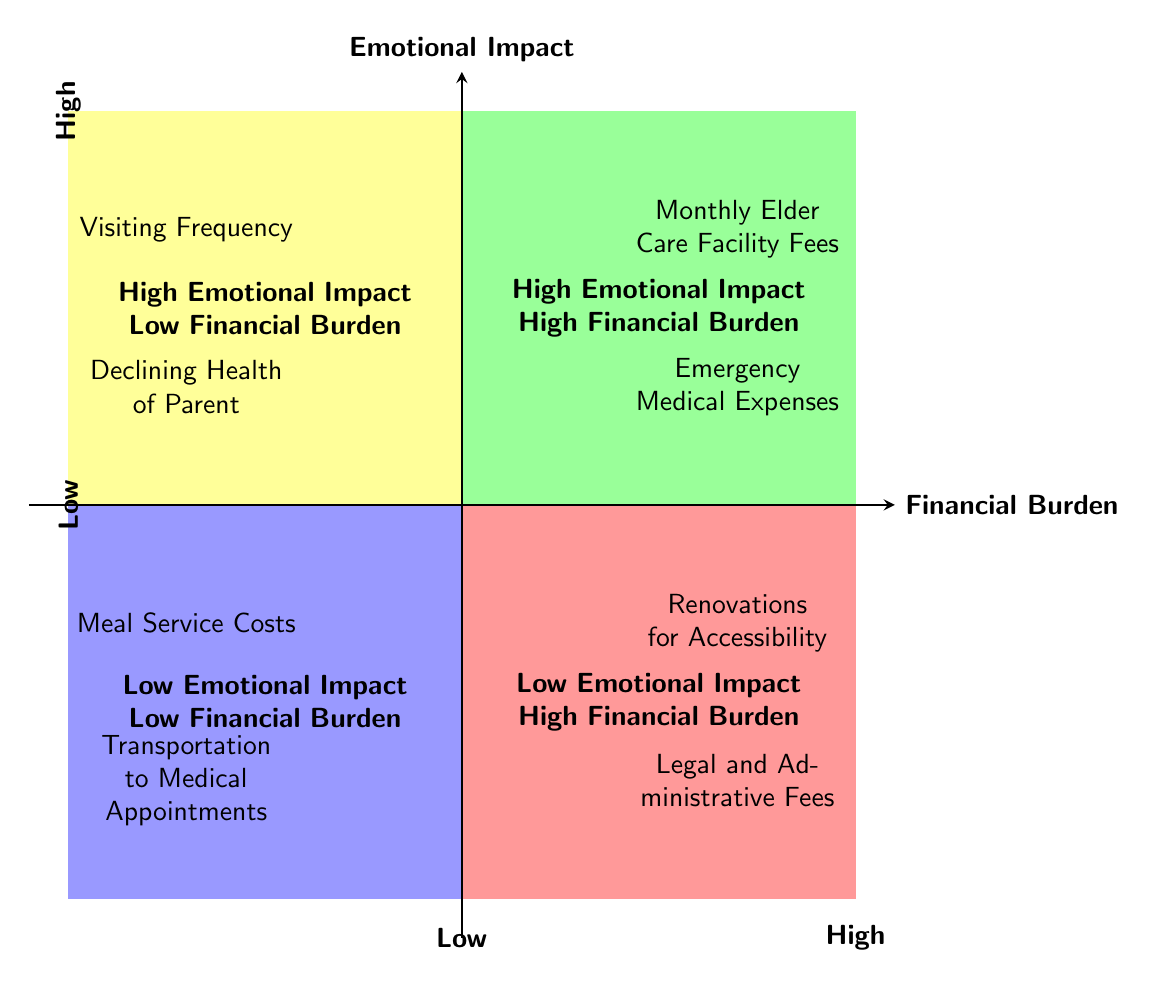What are the two items in the High Emotional Impact High Financial Burden quadrant? The High Emotional Impact High Financial Burden quadrant contains two items: "Monthly Elder Care Facility Fees" and "Emergency Medical Expenses". By locating that quadrant in the diagram, I can directly see the two listed items.
Answer: Monthly Elder Care Facility Fees, Emergency Medical Expenses Which quadrant has the item "Visiting Frequency"? "Visiting Frequency" is located in the High Emotional Impact Low Financial Burden quadrant. By identifying the location of this item in the diagram, we can determine its corresponding quadrant.
Answer: High Emotional Impact Low Financial Burden How many items are in the Low Emotional Impact High Financial Burden quadrant? The Low Emotional Impact High Financial Burden quadrant contains two items: "Renovations for Accessibility" and "Legal and Administrative Fees". Counting the items in that quadrant directly reveals the total number.
Answer: 2 Which quadrant includes the lowest financial burden items? The Low Emotional Impact Low Financial Burden quadrant includes the lowest financial burden items. This quadrant is identified based on its categorization of having both low emotional impact and low financial burden.
Answer: Low Emotional Impact Low Financial Burden What is the emotional impact of "Declining Health of Parent"? "Declining Health of Parent" falls in the High Emotional Impact category. This can be determined by locating the item in the High Emotional Impact Low Financial Burden quadrant and recognizing the emotional aspect of this issue.
Answer: High Which quadrant contains items with both emotional and financial burdens? The High Emotional Impact High Financial Burden quadrant contains items with both emotional and financial burdens. It is specifically categorized as such in the diagram and consists of relevant items listed within it.
Answer: High Emotional Impact High Financial Burden Name the items listed in the Low Emotional Impact Low Financial Burden quadrant. The items listed in the Low Emotional Impact Low Financial Burden quadrant are "Meal Service Costs" and "Transportation to Medical Appointments". By directly examining that quadrant, I can identify these items.
Answer: Meal Service Costs, Transportation to Medical Appointments What is the relationship between "Emergency Medical Expenses" and "High Emotional Impact"? "Emergency Medical Expenses" is associated with a High Emotional Impact, as it is located in the High Emotional Impact High Financial Burden quadrant. Thus, there’s a direct connection of high emotional cost with these expenses.
Answer: High Emotional Impact List one item from each quadrant. From the High Emotional Impact High Financial Burden quadrant, we can take "Monthly Elder Care Facility Fees". From the High Emotional Impact Low Financial Burden quadrant, we can take "Visiting Frequency". From the Low Emotional Impact High Financial Burden quadrant, "Renovations for Accessibility". From the Low Emotional Impact Low Financial Burden quadrant, "Meal Service Costs". By checking each quadrant, I can identify one item from each.
Answer: Monthly Elder Care Facility Fees, Visiting Frequency, Renovations for Accessibility, Meal Service Costs 